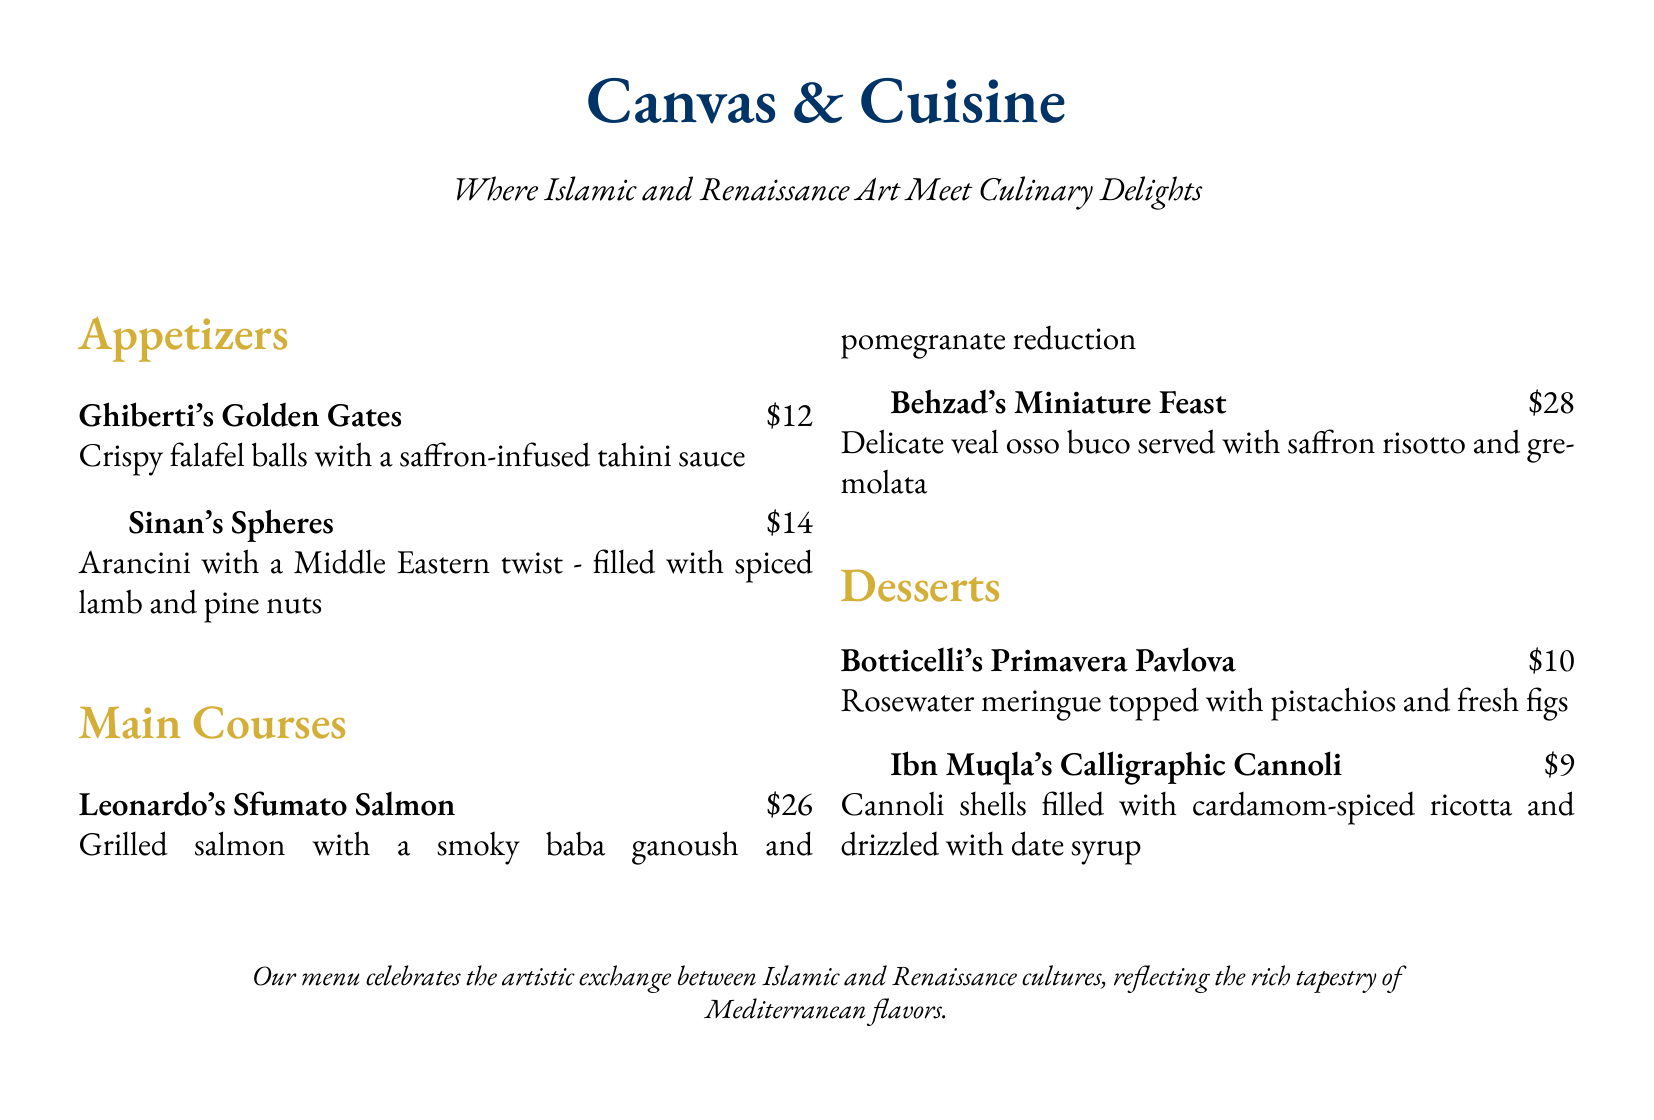What is the name of the appetizer featuring falafel? The appetizer is called "Ghiberti's Golden Gates" and features crispy falafel balls.
Answer: Ghiberti's Golden Gates How much does "Behzad's Miniature Feast" cost? The cost of "Behzad's Miniature Feast" is listed as $28.
Answer: $28 Which dessert is topped with pistachios and fresh figs? The dessert "Botticelli's Primavera Pavlova" is topped with pistachios and fresh figs.
Answer: Botticelli's Primavera Pavlova What is the main ingredient in "Leonardo's Sfumato Salmon"? The main ingredient in "Leonardo's Sfumato Salmon" is grilled salmon.
Answer: Grilled salmon Which chef is associated with cardamom-spiced ricotta in a dessert? The dessert "Ibn Muqla's Calligraphic Cannoli" is associated with cardamom-spiced ricotta.
Answer: Ibn Muqla's Calligraphic Cannoli What type of cuisine does the menu celebrate? The menu celebrates the exchange between Islamic and Renaissance cultures.
Answer: Islamic and Renaissance How many appetizers are listed in the menu? There are 2 appetizers listed in the menu: "Ghiberti's Golden Gates" and "Sinan's Spheres".
Answer: 2 What is the color used for the main course section title? The color used for the main course section title is gold.
Answer: Gold What is unique about "Sinan's Spheres"? "Sinan's Spheres" are arancini with a Middle Eastern twist.
Answer: Middle Eastern twist 